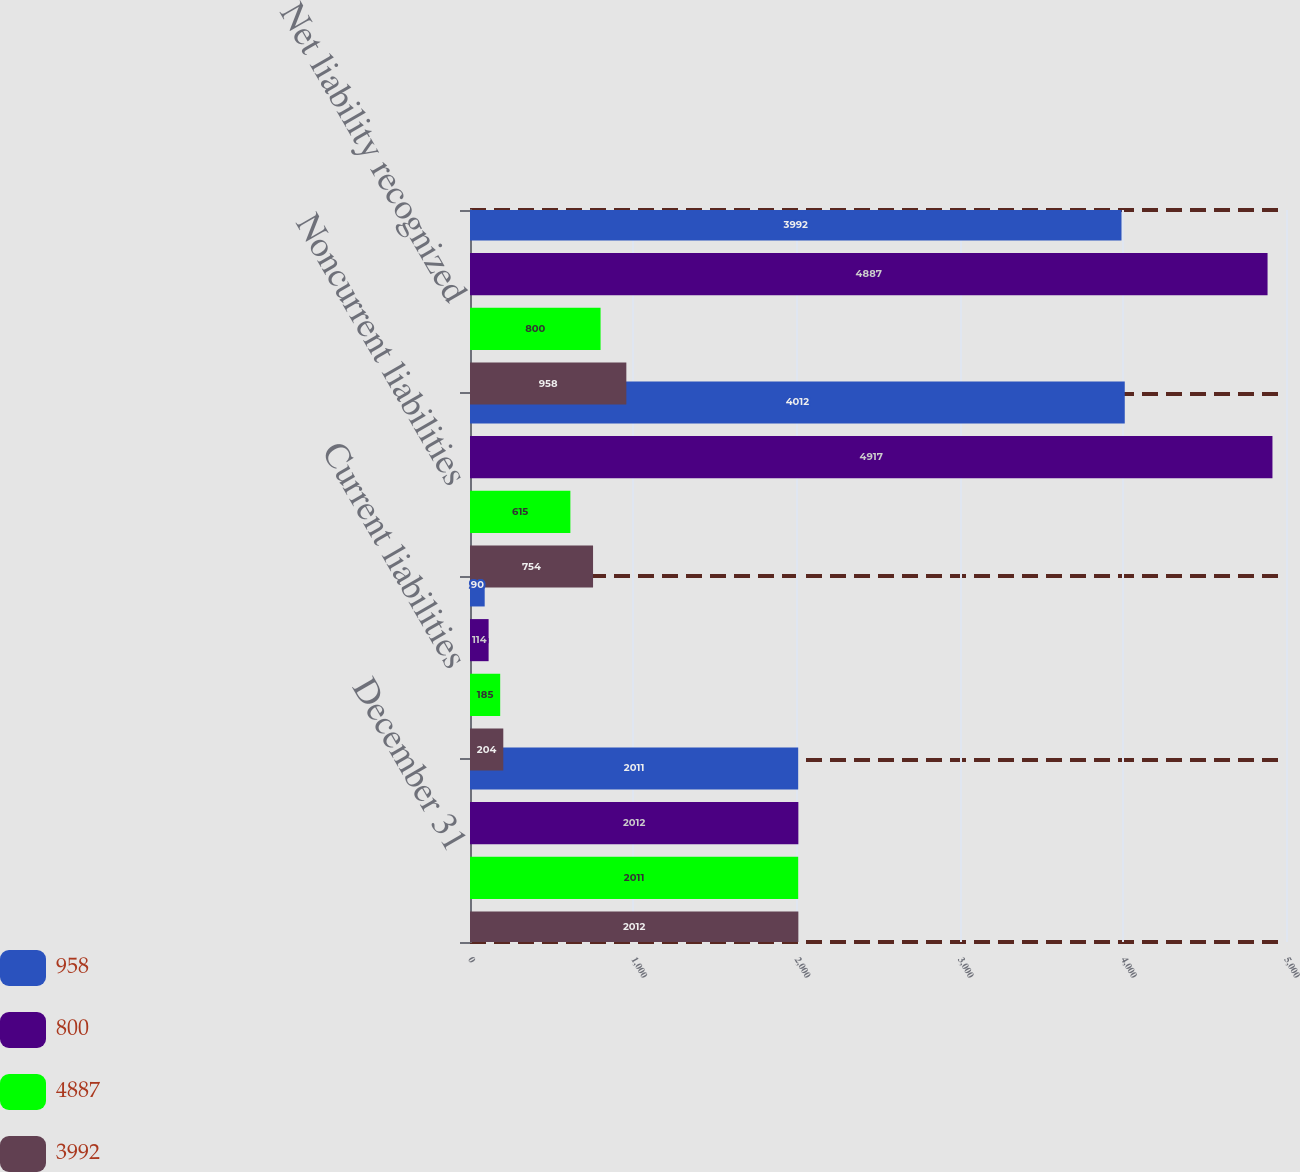<chart> <loc_0><loc_0><loc_500><loc_500><stacked_bar_chart><ecel><fcel>December 31<fcel>Current liabilities<fcel>Noncurrent liabilities<fcel>Net liability recognized<nl><fcel>958<fcel>2011<fcel>90<fcel>4012<fcel>3992<nl><fcel>800<fcel>2012<fcel>114<fcel>4917<fcel>4887<nl><fcel>4887<fcel>2011<fcel>185<fcel>615<fcel>800<nl><fcel>3992<fcel>2012<fcel>204<fcel>754<fcel>958<nl></chart> 